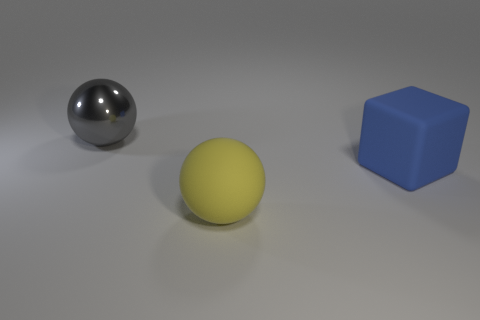Add 3 blue matte blocks. How many objects exist? 6 Subtract all blocks. How many objects are left? 2 Add 3 yellow matte balls. How many yellow matte balls are left? 4 Add 1 gray objects. How many gray objects exist? 2 Subtract 0 red spheres. How many objects are left? 3 Subtract all large blue things. Subtract all balls. How many objects are left? 0 